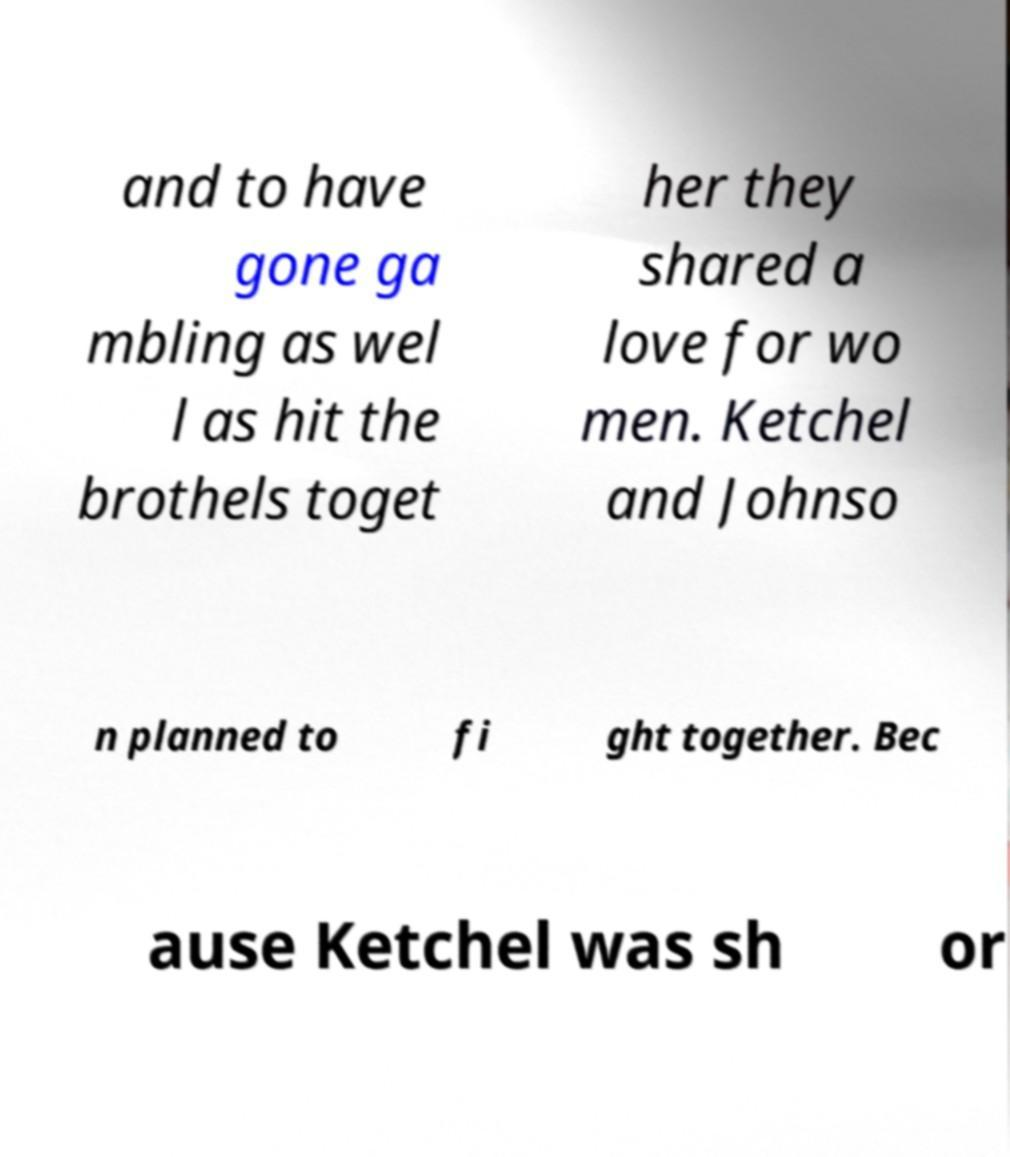Can you read and provide the text displayed in the image?This photo seems to have some interesting text. Can you extract and type it out for me? and to have gone ga mbling as wel l as hit the brothels toget her they shared a love for wo men. Ketchel and Johnso n planned to fi ght together. Bec ause Ketchel was sh or 